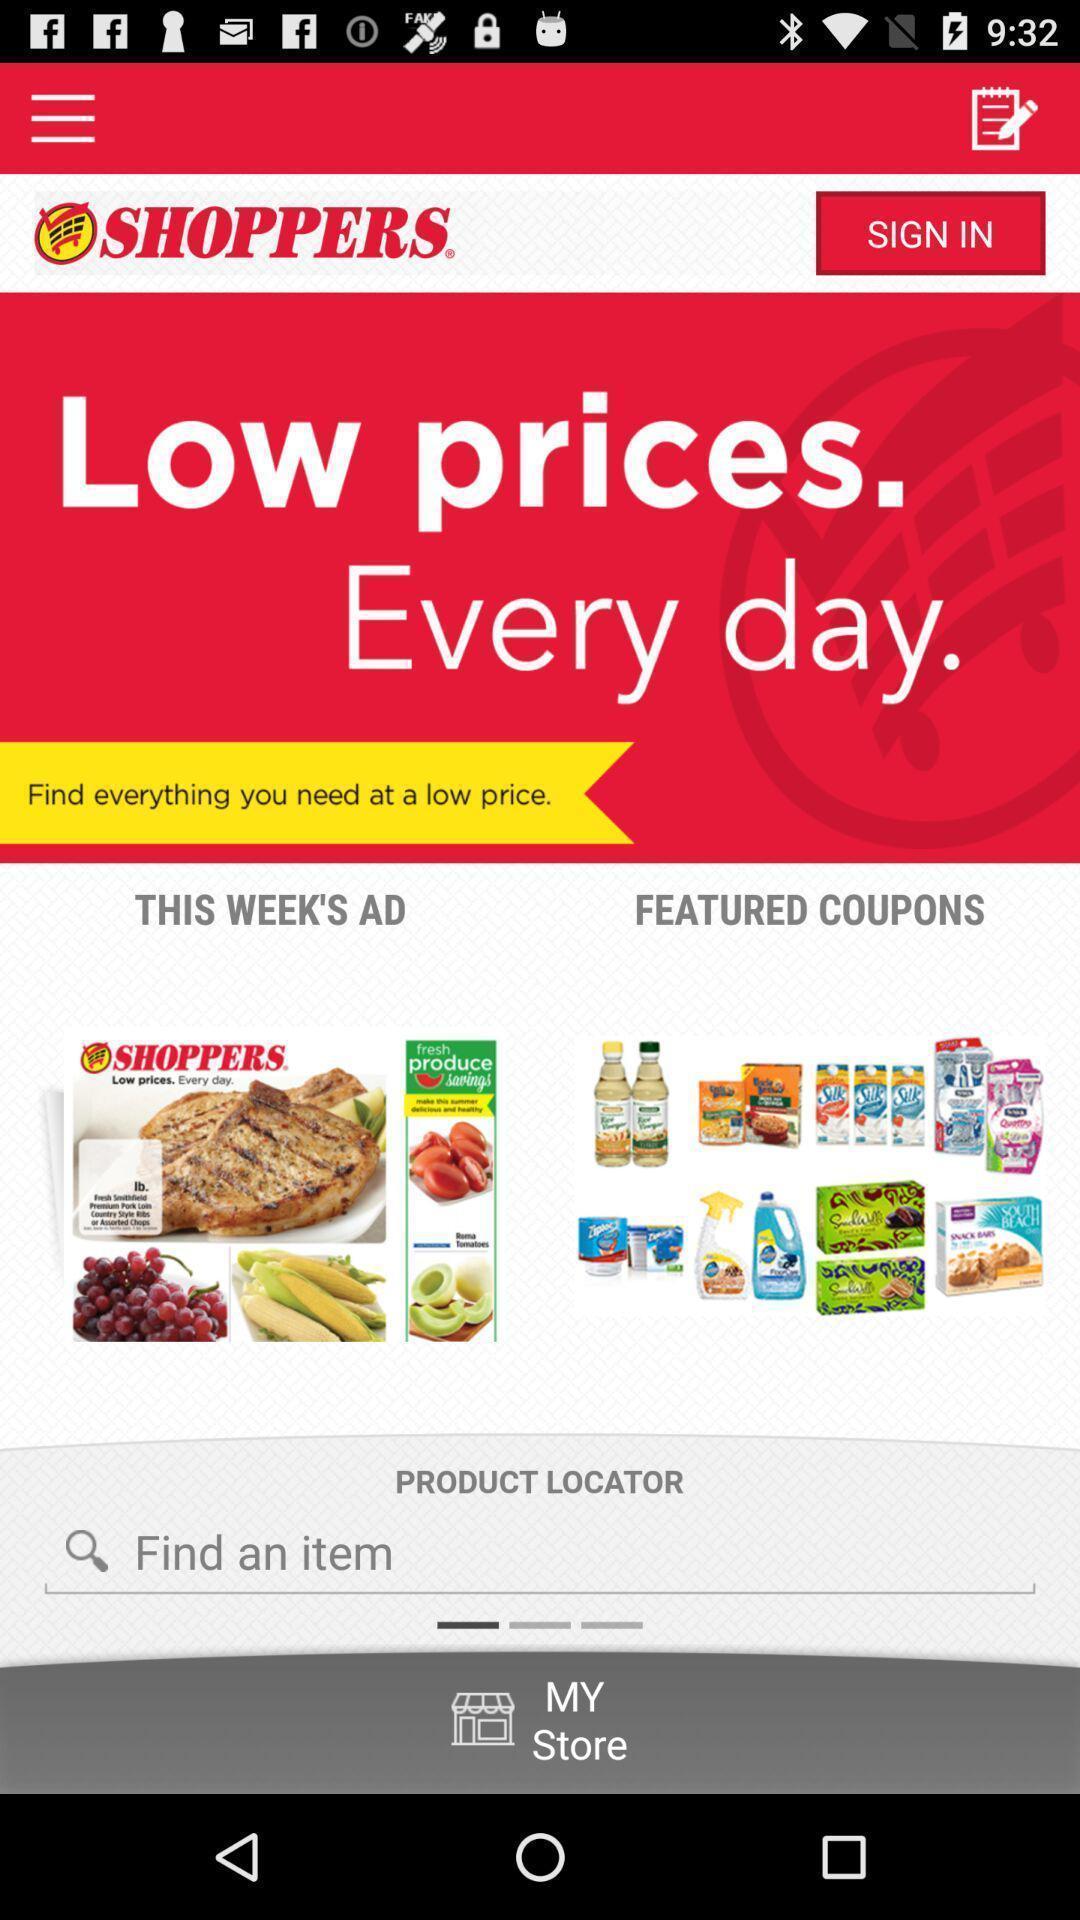Provide a textual representation of this image. Sign in page. 